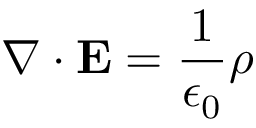Convert formula to latex. <formula><loc_0><loc_0><loc_500><loc_500>\nabla \cdot E = { \frac { 1 } { \epsilon _ { 0 } } } \rho</formula> 